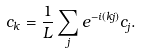Convert formula to latex. <formula><loc_0><loc_0><loc_500><loc_500>c _ { k } = { \frac { 1 } { L } } \sum _ { j } e ^ { - i ( k j ) } c _ { j } .</formula> 